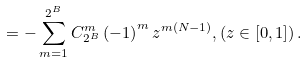<formula> <loc_0><loc_0><loc_500><loc_500>= - \sum _ { m = 1 } ^ { 2 ^ { B } } C _ { 2 ^ { B } } ^ { m } \left ( - 1 \right ) ^ { m } z ^ { m \left ( N - 1 \right ) } , \left ( z \in \left [ 0 , 1 \right ] \right ) .</formula> 